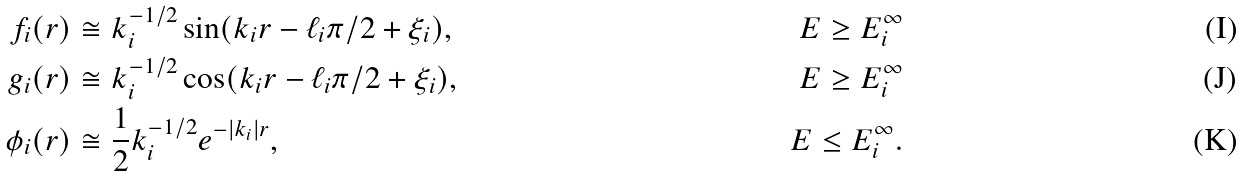<formula> <loc_0><loc_0><loc_500><loc_500>f _ { i } ( r ) & \cong k _ { i } ^ { - 1 / 2 } \sin ( k _ { i } r - \ell _ { i } \pi / 2 + \xi _ { i } ) , & E \geq E _ { i } ^ { \infty } \\ g _ { i } ( r ) & \cong k _ { i } ^ { - 1 / 2 } \cos ( k _ { i } r - \ell _ { i } \pi / 2 + \xi _ { i } ) , & E \geq E _ { i } ^ { \infty } \\ \phi _ { i } ( r ) & \cong \frac { 1 } { 2 } k _ { i } ^ { - 1 / 2 } e ^ { - | k _ { i } | r } , & E \leq E _ { i } ^ { \infty } .</formula> 